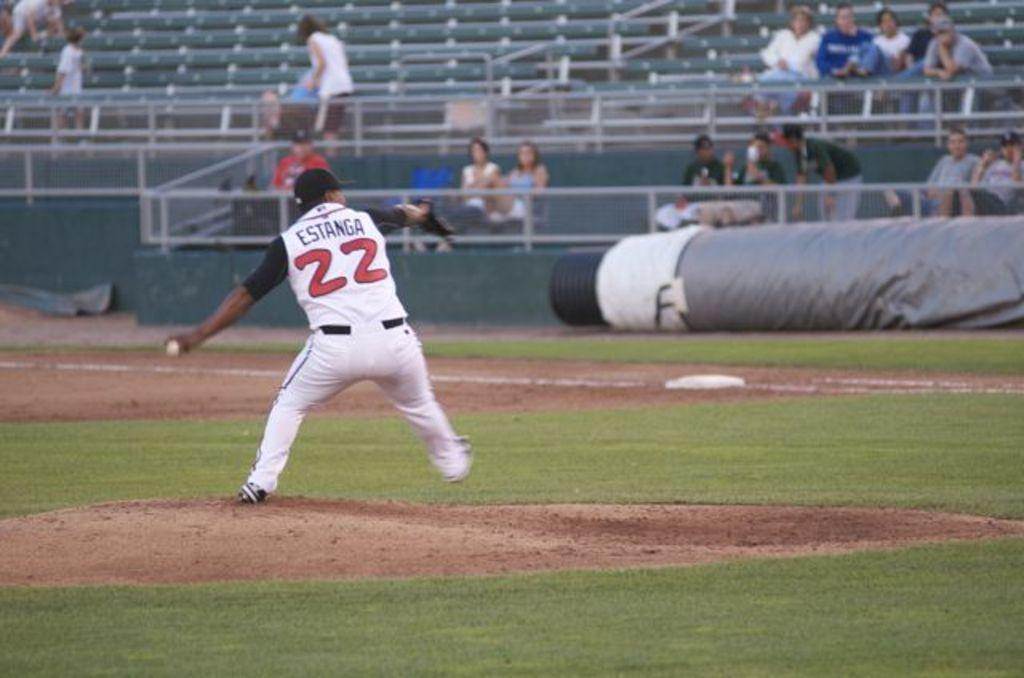Provide a one-sentence caption for the provided image. A man wearing a jersey that says Estanga 22 on a baseball field. 